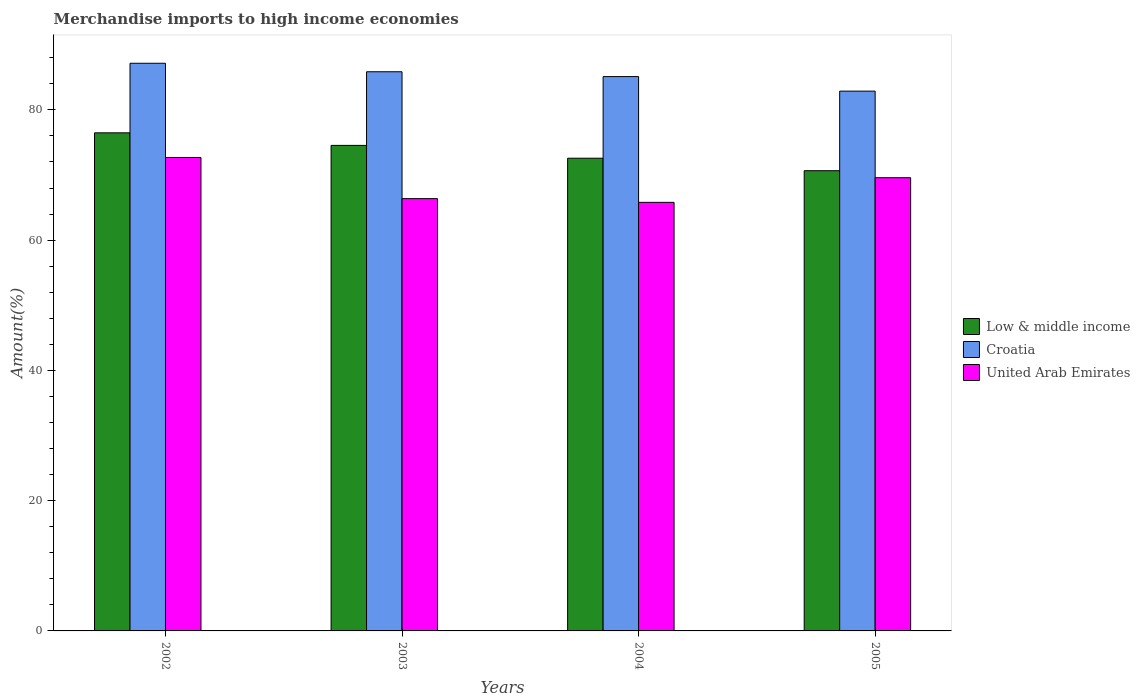How many different coloured bars are there?
Keep it short and to the point. 3. How many groups of bars are there?
Your response must be concise. 4. Are the number of bars on each tick of the X-axis equal?
Offer a terse response. Yes. How many bars are there on the 2nd tick from the left?
Your answer should be compact. 3. How many bars are there on the 3rd tick from the right?
Your response must be concise. 3. What is the percentage of amount earned from merchandise imports in United Arab Emirates in 2004?
Keep it short and to the point. 65.8. Across all years, what is the maximum percentage of amount earned from merchandise imports in United Arab Emirates?
Offer a terse response. 72.7. Across all years, what is the minimum percentage of amount earned from merchandise imports in Croatia?
Offer a terse response. 82.88. What is the total percentage of amount earned from merchandise imports in United Arab Emirates in the graph?
Offer a terse response. 274.46. What is the difference between the percentage of amount earned from merchandise imports in Low & middle income in 2003 and that in 2005?
Provide a succinct answer. 3.89. What is the difference between the percentage of amount earned from merchandise imports in Croatia in 2002 and the percentage of amount earned from merchandise imports in United Arab Emirates in 2004?
Your answer should be compact. 21.36. What is the average percentage of amount earned from merchandise imports in Croatia per year?
Offer a terse response. 85.25. In the year 2003, what is the difference between the percentage of amount earned from merchandise imports in United Arab Emirates and percentage of amount earned from merchandise imports in Croatia?
Ensure brevity in your answer.  -19.48. What is the ratio of the percentage of amount earned from merchandise imports in Croatia in 2002 to that in 2004?
Offer a very short reply. 1.02. Is the difference between the percentage of amount earned from merchandise imports in United Arab Emirates in 2002 and 2005 greater than the difference between the percentage of amount earned from merchandise imports in Croatia in 2002 and 2005?
Give a very brief answer. No. What is the difference between the highest and the second highest percentage of amount earned from merchandise imports in Croatia?
Your response must be concise. 1.3. What is the difference between the highest and the lowest percentage of amount earned from merchandise imports in United Arab Emirates?
Your answer should be very brief. 6.89. Is the sum of the percentage of amount earned from merchandise imports in Croatia in 2002 and 2003 greater than the maximum percentage of amount earned from merchandise imports in Low & middle income across all years?
Offer a very short reply. Yes. What does the 3rd bar from the left in 2005 represents?
Ensure brevity in your answer.  United Arab Emirates. What does the 2nd bar from the right in 2002 represents?
Your answer should be very brief. Croatia. Is it the case that in every year, the sum of the percentage of amount earned from merchandise imports in Croatia and percentage of amount earned from merchandise imports in United Arab Emirates is greater than the percentage of amount earned from merchandise imports in Low & middle income?
Your response must be concise. Yes. How many bars are there?
Ensure brevity in your answer.  12. How many years are there in the graph?
Keep it short and to the point. 4. Are the values on the major ticks of Y-axis written in scientific E-notation?
Offer a very short reply. No. Does the graph contain grids?
Keep it short and to the point. No. How many legend labels are there?
Your answer should be compact. 3. How are the legend labels stacked?
Your answer should be very brief. Vertical. What is the title of the graph?
Keep it short and to the point. Merchandise imports to high income economies. Does "Venezuela" appear as one of the legend labels in the graph?
Offer a very short reply. No. What is the label or title of the Y-axis?
Offer a very short reply. Amount(%). What is the Amount(%) of Low & middle income in 2002?
Provide a short and direct response. 76.48. What is the Amount(%) of Croatia in 2002?
Give a very brief answer. 87.16. What is the Amount(%) of United Arab Emirates in 2002?
Offer a terse response. 72.7. What is the Amount(%) in Low & middle income in 2003?
Provide a succinct answer. 74.55. What is the Amount(%) in Croatia in 2003?
Your response must be concise. 85.85. What is the Amount(%) of United Arab Emirates in 2003?
Provide a short and direct response. 66.37. What is the Amount(%) in Low & middle income in 2004?
Give a very brief answer. 72.58. What is the Amount(%) in Croatia in 2004?
Give a very brief answer. 85.11. What is the Amount(%) of United Arab Emirates in 2004?
Offer a very short reply. 65.8. What is the Amount(%) of Low & middle income in 2005?
Your answer should be compact. 70.66. What is the Amount(%) in Croatia in 2005?
Your response must be concise. 82.88. What is the Amount(%) in United Arab Emirates in 2005?
Your answer should be very brief. 69.59. Across all years, what is the maximum Amount(%) of Low & middle income?
Offer a very short reply. 76.48. Across all years, what is the maximum Amount(%) of Croatia?
Your response must be concise. 87.16. Across all years, what is the maximum Amount(%) in United Arab Emirates?
Offer a terse response. 72.7. Across all years, what is the minimum Amount(%) in Low & middle income?
Provide a short and direct response. 70.66. Across all years, what is the minimum Amount(%) of Croatia?
Your answer should be compact. 82.88. Across all years, what is the minimum Amount(%) of United Arab Emirates?
Give a very brief answer. 65.8. What is the total Amount(%) in Low & middle income in the graph?
Give a very brief answer. 294.26. What is the total Amount(%) in Croatia in the graph?
Your answer should be compact. 341.01. What is the total Amount(%) in United Arab Emirates in the graph?
Make the answer very short. 274.46. What is the difference between the Amount(%) of Low & middle income in 2002 and that in 2003?
Your answer should be compact. 1.93. What is the difference between the Amount(%) in Croatia in 2002 and that in 2003?
Offer a terse response. 1.3. What is the difference between the Amount(%) of United Arab Emirates in 2002 and that in 2003?
Offer a terse response. 6.32. What is the difference between the Amount(%) of Low & middle income in 2002 and that in 2004?
Provide a succinct answer. 3.9. What is the difference between the Amount(%) in Croatia in 2002 and that in 2004?
Make the answer very short. 2.05. What is the difference between the Amount(%) in United Arab Emirates in 2002 and that in 2004?
Offer a very short reply. 6.89. What is the difference between the Amount(%) in Low & middle income in 2002 and that in 2005?
Your answer should be very brief. 5.82. What is the difference between the Amount(%) of Croatia in 2002 and that in 2005?
Offer a terse response. 4.28. What is the difference between the Amount(%) of United Arab Emirates in 2002 and that in 2005?
Offer a terse response. 3.11. What is the difference between the Amount(%) of Low & middle income in 2003 and that in 2004?
Offer a very short reply. 1.97. What is the difference between the Amount(%) in Croatia in 2003 and that in 2004?
Your answer should be very brief. 0.74. What is the difference between the Amount(%) in United Arab Emirates in 2003 and that in 2004?
Offer a terse response. 0.57. What is the difference between the Amount(%) of Low & middle income in 2003 and that in 2005?
Keep it short and to the point. 3.89. What is the difference between the Amount(%) of Croatia in 2003 and that in 2005?
Your answer should be very brief. 2.97. What is the difference between the Amount(%) of United Arab Emirates in 2003 and that in 2005?
Make the answer very short. -3.21. What is the difference between the Amount(%) in Low & middle income in 2004 and that in 2005?
Offer a very short reply. 1.92. What is the difference between the Amount(%) of Croatia in 2004 and that in 2005?
Provide a short and direct response. 2.23. What is the difference between the Amount(%) of United Arab Emirates in 2004 and that in 2005?
Your answer should be very brief. -3.78. What is the difference between the Amount(%) in Low & middle income in 2002 and the Amount(%) in Croatia in 2003?
Provide a short and direct response. -9.38. What is the difference between the Amount(%) in Low & middle income in 2002 and the Amount(%) in United Arab Emirates in 2003?
Ensure brevity in your answer.  10.1. What is the difference between the Amount(%) of Croatia in 2002 and the Amount(%) of United Arab Emirates in 2003?
Your answer should be very brief. 20.79. What is the difference between the Amount(%) in Low & middle income in 2002 and the Amount(%) in Croatia in 2004?
Ensure brevity in your answer.  -8.64. What is the difference between the Amount(%) of Low & middle income in 2002 and the Amount(%) of United Arab Emirates in 2004?
Offer a terse response. 10.67. What is the difference between the Amount(%) of Croatia in 2002 and the Amount(%) of United Arab Emirates in 2004?
Provide a succinct answer. 21.36. What is the difference between the Amount(%) of Low & middle income in 2002 and the Amount(%) of Croatia in 2005?
Give a very brief answer. -6.4. What is the difference between the Amount(%) of Low & middle income in 2002 and the Amount(%) of United Arab Emirates in 2005?
Make the answer very short. 6.89. What is the difference between the Amount(%) of Croatia in 2002 and the Amount(%) of United Arab Emirates in 2005?
Offer a terse response. 17.57. What is the difference between the Amount(%) in Low & middle income in 2003 and the Amount(%) in Croatia in 2004?
Offer a terse response. -10.57. What is the difference between the Amount(%) in Low & middle income in 2003 and the Amount(%) in United Arab Emirates in 2004?
Your response must be concise. 8.74. What is the difference between the Amount(%) of Croatia in 2003 and the Amount(%) of United Arab Emirates in 2004?
Offer a terse response. 20.05. What is the difference between the Amount(%) of Low & middle income in 2003 and the Amount(%) of Croatia in 2005?
Offer a terse response. -8.33. What is the difference between the Amount(%) in Low & middle income in 2003 and the Amount(%) in United Arab Emirates in 2005?
Offer a terse response. 4.96. What is the difference between the Amount(%) in Croatia in 2003 and the Amount(%) in United Arab Emirates in 2005?
Keep it short and to the point. 16.27. What is the difference between the Amount(%) in Low & middle income in 2004 and the Amount(%) in Croatia in 2005?
Offer a very short reply. -10.3. What is the difference between the Amount(%) in Low & middle income in 2004 and the Amount(%) in United Arab Emirates in 2005?
Ensure brevity in your answer.  2.99. What is the difference between the Amount(%) in Croatia in 2004 and the Amount(%) in United Arab Emirates in 2005?
Your answer should be compact. 15.53. What is the average Amount(%) of Low & middle income per year?
Ensure brevity in your answer.  73.57. What is the average Amount(%) in Croatia per year?
Ensure brevity in your answer.  85.25. What is the average Amount(%) of United Arab Emirates per year?
Keep it short and to the point. 68.61. In the year 2002, what is the difference between the Amount(%) of Low & middle income and Amount(%) of Croatia?
Your answer should be very brief. -10.68. In the year 2002, what is the difference between the Amount(%) of Low & middle income and Amount(%) of United Arab Emirates?
Your answer should be very brief. 3.78. In the year 2002, what is the difference between the Amount(%) of Croatia and Amount(%) of United Arab Emirates?
Offer a terse response. 14.46. In the year 2003, what is the difference between the Amount(%) in Low & middle income and Amount(%) in Croatia?
Offer a terse response. -11.31. In the year 2003, what is the difference between the Amount(%) of Low & middle income and Amount(%) of United Arab Emirates?
Your answer should be very brief. 8.17. In the year 2003, what is the difference between the Amount(%) in Croatia and Amount(%) in United Arab Emirates?
Offer a terse response. 19.48. In the year 2004, what is the difference between the Amount(%) of Low & middle income and Amount(%) of Croatia?
Ensure brevity in your answer.  -12.53. In the year 2004, what is the difference between the Amount(%) of Low & middle income and Amount(%) of United Arab Emirates?
Offer a very short reply. 6.78. In the year 2004, what is the difference between the Amount(%) of Croatia and Amount(%) of United Arab Emirates?
Offer a terse response. 19.31. In the year 2005, what is the difference between the Amount(%) in Low & middle income and Amount(%) in Croatia?
Provide a short and direct response. -12.22. In the year 2005, what is the difference between the Amount(%) in Low & middle income and Amount(%) in United Arab Emirates?
Your answer should be compact. 1.07. In the year 2005, what is the difference between the Amount(%) of Croatia and Amount(%) of United Arab Emirates?
Make the answer very short. 13.29. What is the ratio of the Amount(%) in Low & middle income in 2002 to that in 2003?
Provide a short and direct response. 1.03. What is the ratio of the Amount(%) in Croatia in 2002 to that in 2003?
Offer a very short reply. 1.02. What is the ratio of the Amount(%) in United Arab Emirates in 2002 to that in 2003?
Your response must be concise. 1.1. What is the ratio of the Amount(%) of Low & middle income in 2002 to that in 2004?
Your answer should be very brief. 1.05. What is the ratio of the Amount(%) in Croatia in 2002 to that in 2004?
Offer a very short reply. 1.02. What is the ratio of the Amount(%) in United Arab Emirates in 2002 to that in 2004?
Offer a very short reply. 1.1. What is the ratio of the Amount(%) of Low & middle income in 2002 to that in 2005?
Ensure brevity in your answer.  1.08. What is the ratio of the Amount(%) of Croatia in 2002 to that in 2005?
Provide a succinct answer. 1.05. What is the ratio of the Amount(%) in United Arab Emirates in 2002 to that in 2005?
Offer a terse response. 1.04. What is the ratio of the Amount(%) of Low & middle income in 2003 to that in 2004?
Give a very brief answer. 1.03. What is the ratio of the Amount(%) of Croatia in 2003 to that in 2004?
Ensure brevity in your answer.  1.01. What is the ratio of the Amount(%) of United Arab Emirates in 2003 to that in 2004?
Your response must be concise. 1.01. What is the ratio of the Amount(%) of Low & middle income in 2003 to that in 2005?
Your answer should be very brief. 1.05. What is the ratio of the Amount(%) in Croatia in 2003 to that in 2005?
Your answer should be compact. 1.04. What is the ratio of the Amount(%) in United Arab Emirates in 2003 to that in 2005?
Your answer should be compact. 0.95. What is the ratio of the Amount(%) in Low & middle income in 2004 to that in 2005?
Keep it short and to the point. 1.03. What is the ratio of the Amount(%) of Croatia in 2004 to that in 2005?
Keep it short and to the point. 1.03. What is the ratio of the Amount(%) in United Arab Emirates in 2004 to that in 2005?
Make the answer very short. 0.95. What is the difference between the highest and the second highest Amount(%) of Low & middle income?
Make the answer very short. 1.93. What is the difference between the highest and the second highest Amount(%) in Croatia?
Offer a very short reply. 1.3. What is the difference between the highest and the second highest Amount(%) in United Arab Emirates?
Your answer should be compact. 3.11. What is the difference between the highest and the lowest Amount(%) in Low & middle income?
Your answer should be very brief. 5.82. What is the difference between the highest and the lowest Amount(%) of Croatia?
Offer a terse response. 4.28. What is the difference between the highest and the lowest Amount(%) of United Arab Emirates?
Provide a short and direct response. 6.89. 